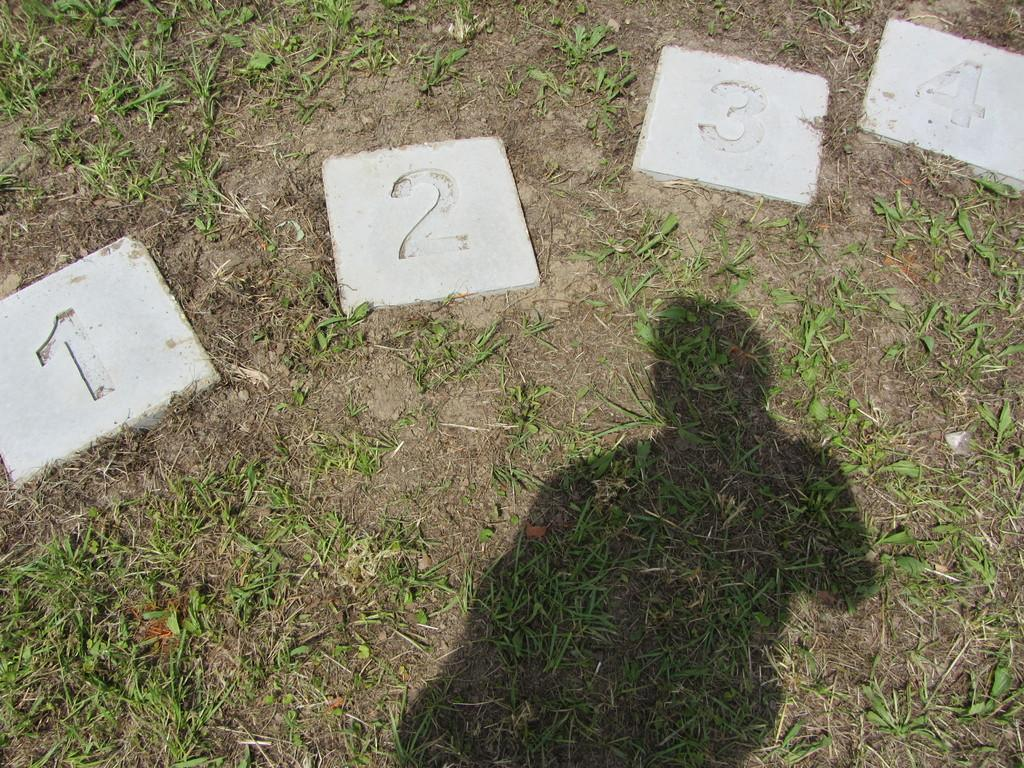What can be seen in the image that resembles a person? There is a shadow of a person in the image. What type of ground is visible at the bottom of the image? Grass is visible at the bottom of the image. What kind of objects with numbers are present in the image? There are tiles with numerical numbers printed on them in the image. What type of scientific experiment is being conducted in the image? There is no indication of a scientific experiment being conducted in the image. Can you see any celestial bodies in the image? There is no reference to space or celestial bodies in the image. 